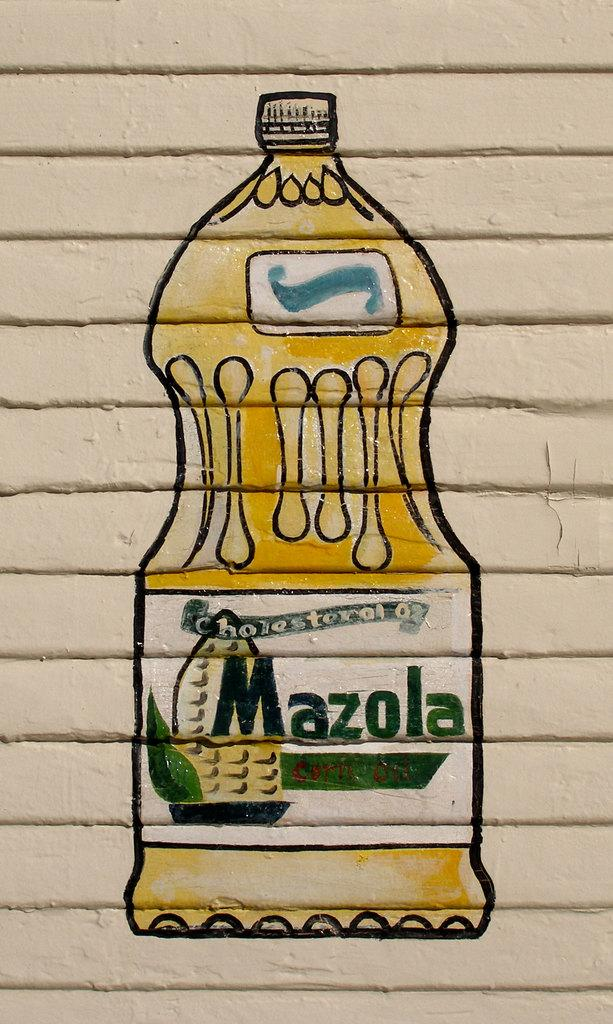<image>
Render a clear and concise summary of the photo. a mural painted on a wall that says 'cholesteral 0%, mazolal' 